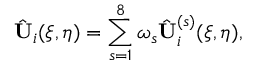<formula> <loc_0><loc_0><loc_500><loc_500>\hat { U } _ { i } ( \xi , \eta ) = \sum _ { s = 1 } ^ { 8 } \omega _ { s } \hat { U } _ { i } ^ { ( s ) } ( \xi , \eta ) ,</formula> 